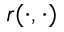Convert formula to latex. <formula><loc_0><loc_0><loc_500><loc_500>r ( \cdot , \cdot )</formula> 